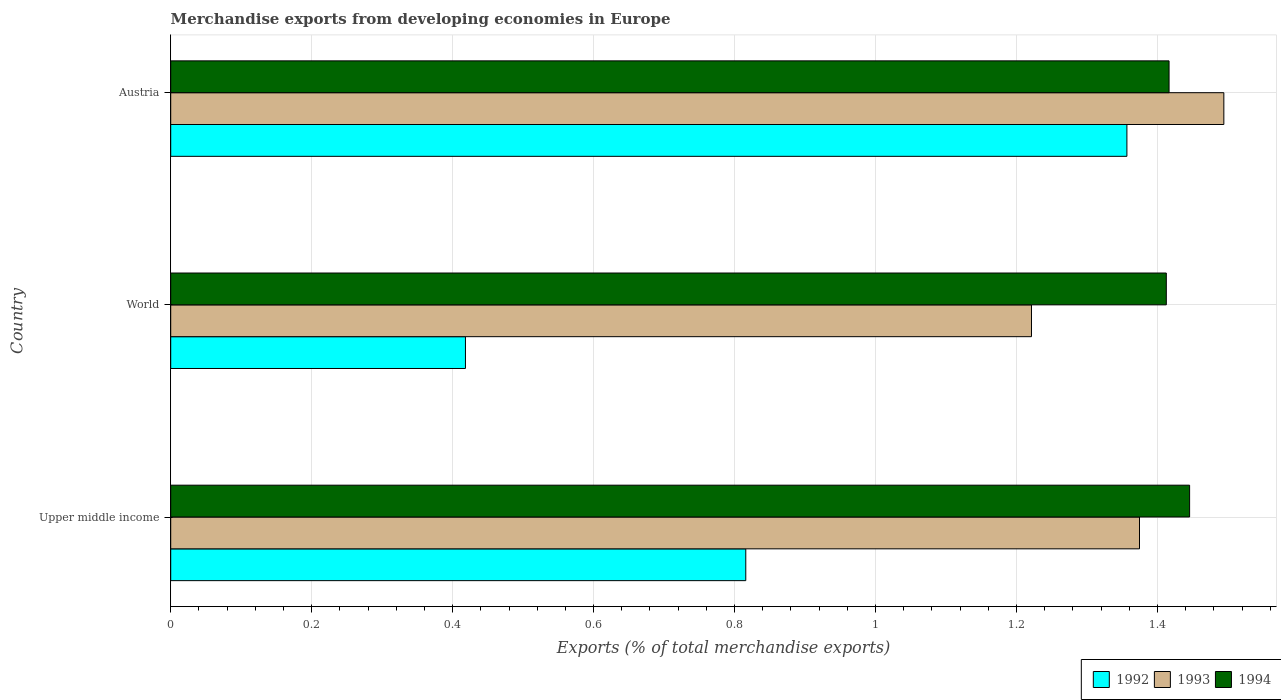How many different coloured bars are there?
Provide a short and direct response. 3. Are the number of bars on each tick of the Y-axis equal?
Ensure brevity in your answer.  Yes. How many bars are there on the 1st tick from the bottom?
Offer a very short reply. 3. What is the label of the 3rd group of bars from the top?
Your response must be concise. Upper middle income. In how many cases, is the number of bars for a given country not equal to the number of legend labels?
Offer a terse response. 0. What is the percentage of total merchandise exports in 1994 in Upper middle income?
Ensure brevity in your answer.  1.45. Across all countries, what is the maximum percentage of total merchandise exports in 1992?
Keep it short and to the point. 1.36. Across all countries, what is the minimum percentage of total merchandise exports in 1993?
Give a very brief answer. 1.22. In which country was the percentage of total merchandise exports in 1994 minimum?
Give a very brief answer. World. What is the total percentage of total merchandise exports in 1993 in the graph?
Offer a very short reply. 4.09. What is the difference between the percentage of total merchandise exports in 1994 in Austria and that in Upper middle income?
Ensure brevity in your answer.  -0.03. What is the difference between the percentage of total merchandise exports in 1993 in Upper middle income and the percentage of total merchandise exports in 1994 in Austria?
Provide a short and direct response. -0.04. What is the average percentage of total merchandise exports in 1992 per country?
Make the answer very short. 0.86. What is the difference between the percentage of total merchandise exports in 1994 and percentage of total merchandise exports in 1992 in World?
Your response must be concise. 0.99. What is the ratio of the percentage of total merchandise exports in 1992 in Austria to that in Upper middle income?
Make the answer very short. 1.66. Is the difference between the percentage of total merchandise exports in 1994 in Austria and Upper middle income greater than the difference between the percentage of total merchandise exports in 1992 in Austria and Upper middle income?
Offer a very short reply. No. What is the difference between the highest and the second highest percentage of total merchandise exports in 1992?
Provide a succinct answer. 0.54. What is the difference between the highest and the lowest percentage of total merchandise exports in 1994?
Give a very brief answer. 0.03. Is the sum of the percentage of total merchandise exports in 1993 in Austria and Upper middle income greater than the maximum percentage of total merchandise exports in 1992 across all countries?
Provide a short and direct response. Yes. What does the 1st bar from the top in Upper middle income represents?
Make the answer very short. 1994. How many bars are there?
Offer a very short reply. 9. What is the difference between two consecutive major ticks on the X-axis?
Provide a succinct answer. 0.2. Are the values on the major ticks of X-axis written in scientific E-notation?
Your answer should be compact. No. Does the graph contain any zero values?
Keep it short and to the point. No. Where does the legend appear in the graph?
Provide a succinct answer. Bottom right. How many legend labels are there?
Keep it short and to the point. 3. What is the title of the graph?
Provide a succinct answer. Merchandise exports from developing economies in Europe. Does "1982" appear as one of the legend labels in the graph?
Offer a terse response. No. What is the label or title of the X-axis?
Your response must be concise. Exports (% of total merchandise exports). What is the label or title of the Y-axis?
Give a very brief answer. Country. What is the Exports (% of total merchandise exports) in 1992 in Upper middle income?
Your answer should be very brief. 0.82. What is the Exports (% of total merchandise exports) in 1993 in Upper middle income?
Ensure brevity in your answer.  1.37. What is the Exports (% of total merchandise exports) in 1994 in Upper middle income?
Keep it short and to the point. 1.45. What is the Exports (% of total merchandise exports) of 1992 in World?
Your answer should be compact. 0.42. What is the Exports (% of total merchandise exports) in 1993 in World?
Your answer should be very brief. 1.22. What is the Exports (% of total merchandise exports) in 1994 in World?
Offer a very short reply. 1.41. What is the Exports (% of total merchandise exports) in 1992 in Austria?
Your response must be concise. 1.36. What is the Exports (% of total merchandise exports) of 1993 in Austria?
Your answer should be very brief. 1.49. What is the Exports (% of total merchandise exports) of 1994 in Austria?
Offer a terse response. 1.42. Across all countries, what is the maximum Exports (% of total merchandise exports) of 1992?
Provide a short and direct response. 1.36. Across all countries, what is the maximum Exports (% of total merchandise exports) in 1993?
Offer a very short reply. 1.49. Across all countries, what is the maximum Exports (% of total merchandise exports) of 1994?
Keep it short and to the point. 1.45. Across all countries, what is the minimum Exports (% of total merchandise exports) in 1992?
Provide a succinct answer. 0.42. Across all countries, what is the minimum Exports (% of total merchandise exports) of 1993?
Offer a terse response. 1.22. Across all countries, what is the minimum Exports (% of total merchandise exports) of 1994?
Make the answer very short. 1.41. What is the total Exports (% of total merchandise exports) of 1992 in the graph?
Give a very brief answer. 2.59. What is the total Exports (% of total merchandise exports) of 1993 in the graph?
Your response must be concise. 4.09. What is the total Exports (% of total merchandise exports) of 1994 in the graph?
Offer a terse response. 4.27. What is the difference between the Exports (% of total merchandise exports) of 1992 in Upper middle income and that in World?
Offer a terse response. 0.4. What is the difference between the Exports (% of total merchandise exports) in 1993 in Upper middle income and that in World?
Provide a succinct answer. 0.15. What is the difference between the Exports (% of total merchandise exports) in 1994 in Upper middle income and that in World?
Your answer should be very brief. 0.03. What is the difference between the Exports (% of total merchandise exports) of 1992 in Upper middle income and that in Austria?
Your response must be concise. -0.54. What is the difference between the Exports (% of total merchandise exports) of 1993 in Upper middle income and that in Austria?
Give a very brief answer. -0.12. What is the difference between the Exports (% of total merchandise exports) in 1994 in Upper middle income and that in Austria?
Your answer should be compact. 0.03. What is the difference between the Exports (% of total merchandise exports) in 1992 in World and that in Austria?
Provide a succinct answer. -0.94. What is the difference between the Exports (% of total merchandise exports) in 1993 in World and that in Austria?
Ensure brevity in your answer.  -0.27. What is the difference between the Exports (% of total merchandise exports) of 1994 in World and that in Austria?
Provide a short and direct response. -0. What is the difference between the Exports (% of total merchandise exports) of 1992 in Upper middle income and the Exports (% of total merchandise exports) of 1993 in World?
Your answer should be compact. -0.41. What is the difference between the Exports (% of total merchandise exports) in 1992 in Upper middle income and the Exports (% of total merchandise exports) in 1994 in World?
Your response must be concise. -0.6. What is the difference between the Exports (% of total merchandise exports) in 1993 in Upper middle income and the Exports (% of total merchandise exports) in 1994 in World?
Your answer should be very brief. -0.04. What is the difference between the Exports (% of total merchandise exports) in 1992 in Upper middle income and the Exports (% of total merchandise exports) in 1993 in Austria?
Your response must be concise. -0.68. What is the difference between the Exports (% of total merchandise exports) in 1992 in Upper middle income and the Exports (% of total merchandise exports) in 1994 in Austria?
Keep it short and to the point. -0.6. What is the difference between the Exports (% of total merchandise exports) in 1993 in Upper middle income and the Exports (% of total merchandise exports) in 1994 in Austria?
Your answer should be very brief. -0.04. What is the difference between the Exports (% of total merchandise exports) in 1992 in World and the Exports (% of total merchandise exports) in 1993 in Austria?
Keep it short and to the point. -1.08. What is the difference between the Exports (% of total merchandise exports) in 1992 in World and the Exports (% of total merchandise exports) in 1994 in Austria?
Give a very brief answer. -1. What is the difference between the Exports (% of total merchandise exports) in 1993 in World and the Exports (% of total merchandise exports) in 1994 in Austria?
Provide a short and direct response. -0.2. What is the average Exports (% of total merchandise exports) of 1992 per country?
Offer a very short reply. 0.86. What is the average Exports (% of total merchandise exports) in 1993 per country?
Offer a very short reply. 1.36. What is the average Exports (% of total merchandise exports) of 1994 per country?
Your response must be concise. 1.42. What is the difference between the Exports (% of total merchandise exports) in 1992 and Exports (% of total merchandise exports) in 1993 in Upper middle income?
Offer a terse response. -0.56. What is the difference between the Exports (% of total merchandise exports) in 1992 and Exports (% of total merchandise exports) in 1994 in Upper middle income?
Offer a very short reply. -0.63. What is the difference between the Exports (% of total merchandise exports) of 1993 and Exports (% of total merchandise exports) of 1994 in Upper middle income?
Your response must be concise. -0.07. What is the difference between the Exports (% of total merchandise exports) of 1992 and Exports (% of total merchandise exports) of 1993 in World?
Provide a succinct answer. -0.8. What is the difference between the Exports (% of total merchandise exports) in 1992 and Exports (% of total merchandise exports) in 1994 in World?
Your answer should be very brief. -0.99. What is the difference between the Exports (% of total merchandise exports) of 1993 and Exports (% of total merchandise exports) of 1994 in World?
Your answer should be very brief. -0.19. What is the difference between the Exports (% of total merchandise exports) in 1992 and Exports (% of total merchandise exports) in 1993 in Austria?
Give a very brief answer. -0.14. What is the difference between the Exports (% of total merchandise exports) of 1992 and Exports (% of total merchandise exports) of 1994 in Austria?
Keep it short and to the point. -0.06. What is the difference between the Exports (% of total merchandise exports) in 1993 and Exports (% of total merchandise exports) in 1994 in Austria?
Your response must be concise. 0.08. What is the ratio of the Exports (% of total merchandise exports) in 1992 in Upper middle income to that in World?
Provide a short and direct response. 1.95. What is the ratio of the Exports (% of total merchandise exports) of 1993 in Upper middle income to that in World?
Offer a very short reply. 1.13. What is the ratio of the Exports (% of total merchandise exports) in 1994 in Upper middle income to that in World?
Provide a short and direct response. 1.02. What is the ratio of the Exports (% of total merchandise exports) in 1992 in Upper middle income to that in Austria?
Offer a terse response. 0.6. What is the ratio of the Exports (% of total merchandise exports) of 1993 in Upper middle income to that in Austria?
Provide a succinct answer. 0.92. What is the ratio of the Exports (% of total merchandise exports) of 1994 in Upper middle income to that in Austria?
Keep it short and to the point. 1.02. What is the ratio of the Exports (% of total merchandise exports) in 1992 in World to that in Austria?
Offer a terse response. 0.31. What is the ratio of the Exports (% of total merchandise exports) in 1993 in World to that in Austria?
Keep it short and to the point. 0.82. What is the difference between the highest and the second highest Exports (% of total merchandise exports) of 1992?
Your answer should be compact. 0.54. What is the difference between the highest and the second highest Exports (% of total merchandise exports) of 1993?
Ensure brevity in your answer.  0.12. What is the difference between the highest and the second highest Exports (% of total merchandise exports) of 1994?
Keep it short and to the point. 0.03. What is the difference between the highest and the lowest Exports (% of total merchandise exports) of 1992?
Your answer should be very brief. 0.94. What is the difference between the highest and the lowest Exports (% of total merchandise exports) in 1993?
Your response must be concise. 0.27. What is the difference between the highest and the lowest Exports (% of total merchandise exports) in 1994?
Your answer should be compact. 0.03. 